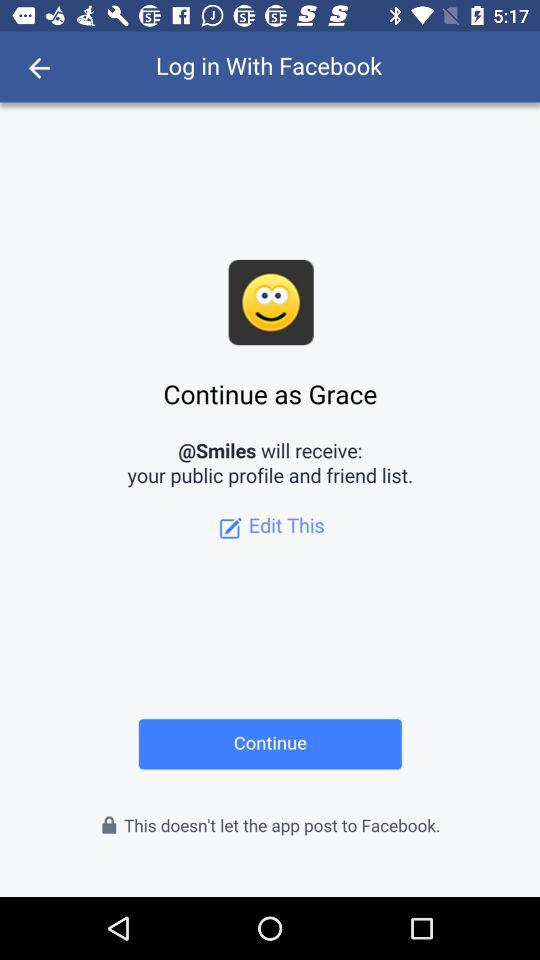What is the name of the user? The name of the user is Grace. 